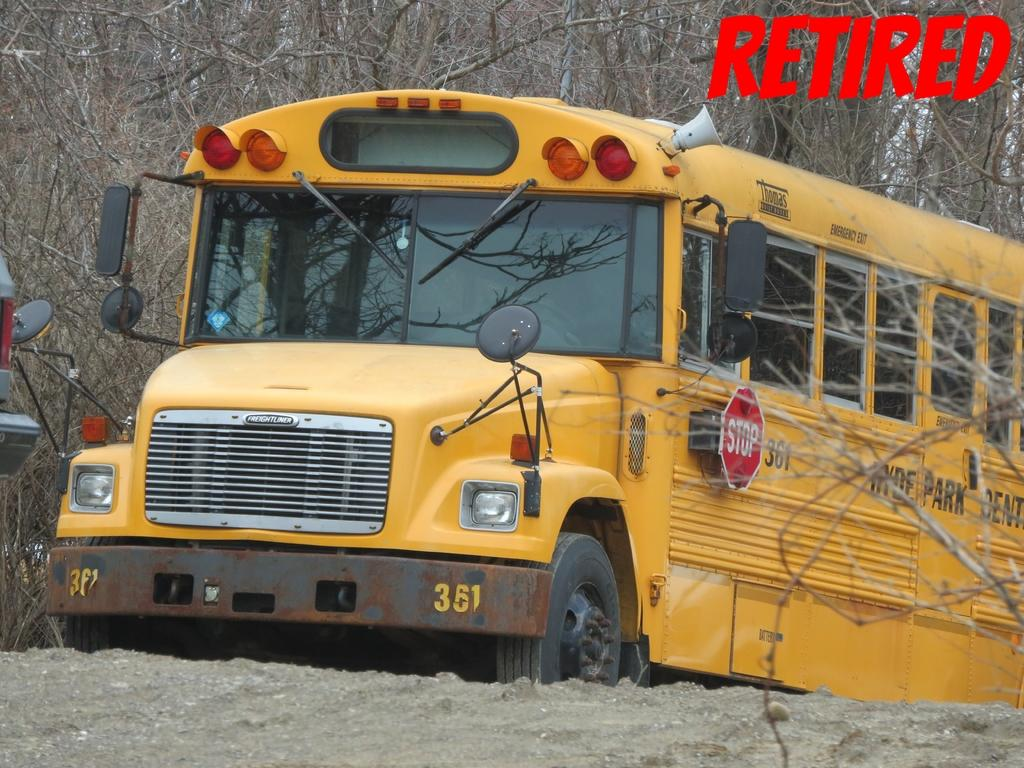How many vehicles can be seen in the image? There are two vehicles in the image. Can you describe the vehicles in the image? Unfortunately, the facts provided do not give any details about the vehicles. What can be seen in the background of the image? There are dry trees in the background of the image. What theory is being exchanged between the plants in the image? There are no plants present in the image, and therefore no exchange of theories can be observed. 